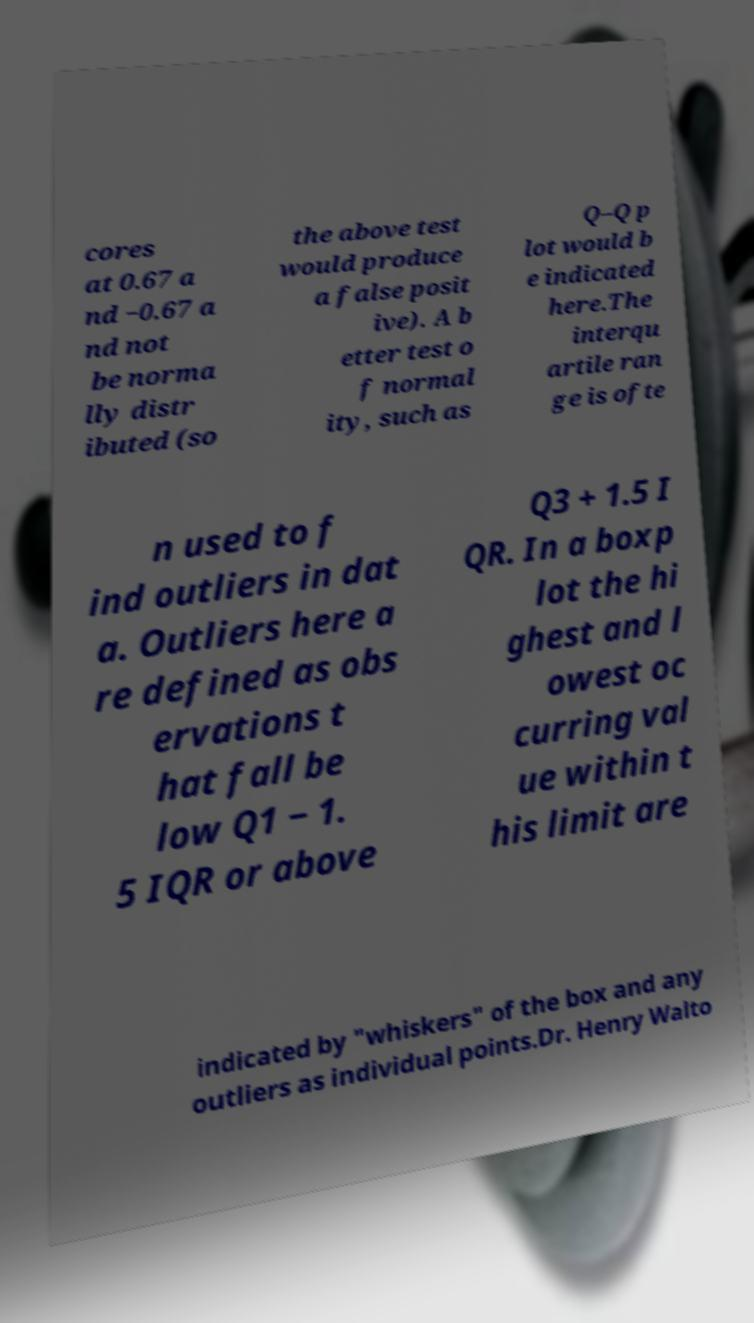What messages or text are displayed in this image? I need them in a readable, typed format. cores at 0.67 a nd −0.67 a nd not be norma lly distr ibuted (so the above test would produce a false posit ive). A b etter test o f normal ity, such as Q–Q p lot would b e indicated here.The interqu artile ran ge is ofte n used to f ind outliers in dat a. Outliers here a re defined as obs ervations t hat fall be low Q1 − 1. 5 IQR or above Q3 + 1.5 I QR. In a boxp lot the hi ghest and l owest oc curring val ue within t his limit are indicated by "whiskers" of the box and any outliers as individual points.Dr. Henry Walto 